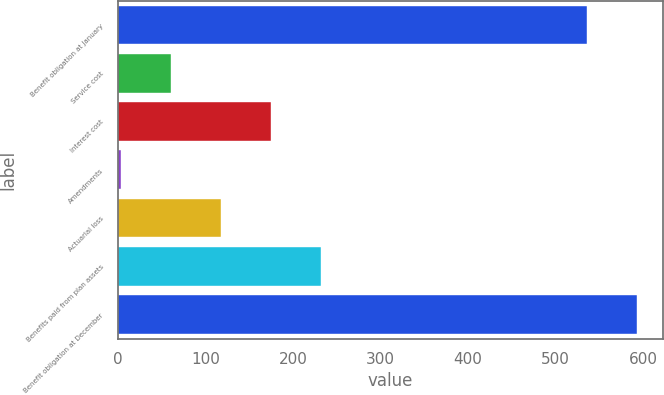Convert chart. <chart><loc_0><loc_0><loc_500><loc_500><bar_chart><fcel>Benefit obligation at January<fcel>Service cost<fcel>Interest cost<fcel>Amendments<fcel>Actuarial loss<fcel>Benefits paid from plan assets<fcel>Benefit obligation at December<nl><fcel>535.9<fcel>60.95<fcel>175.25<fcel>3.8<fcel>118.1<fcel>232.4<fcel>593.05<nl></chart> 